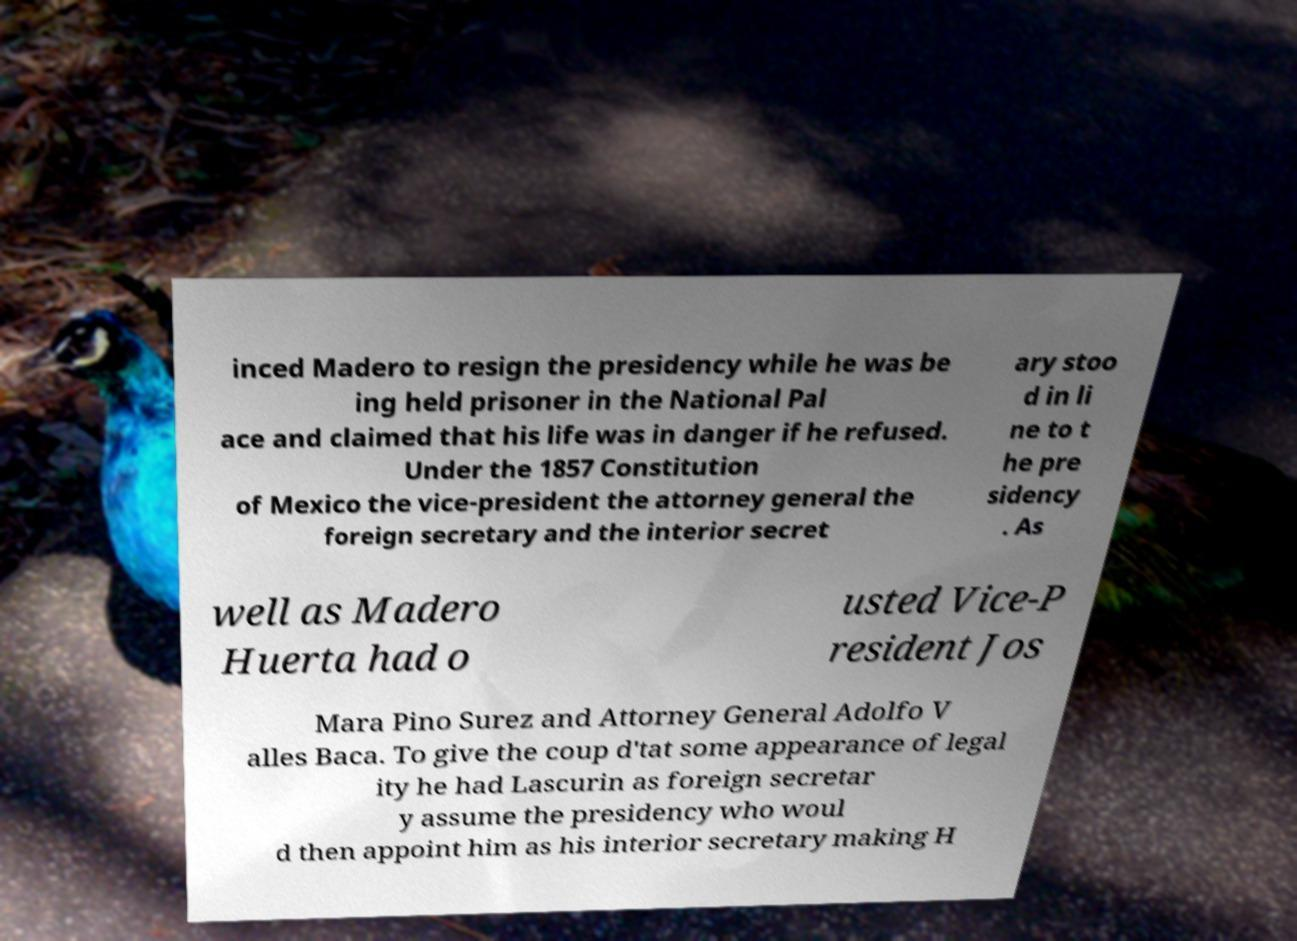Can you accurately transcribe the text from the provided image for me? inced Madero to resign the presidency while he was be ing held prisoner in the National Pal ace and claimed that his life was in danger if he refused. Under the 1857 Constitution of Mexico the vice-president the attorney general the foreign secretary and the interior secret ary stoo d in li ne to t he pre sidency . As well as Madero Huerta had o usted Vice-P resident Jos Mara Pino Surez and Attorney General Adolfo V alles Baca. To give the coup d'tat some appearance of legal ity he had Lascurin as foreign secretar y assume the presidency who woul d then appoint him as his interior secretary making H 